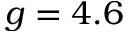<formula> <loc_0><loc_0><loc_500><loc_500>g = 4 . 6</formula> 